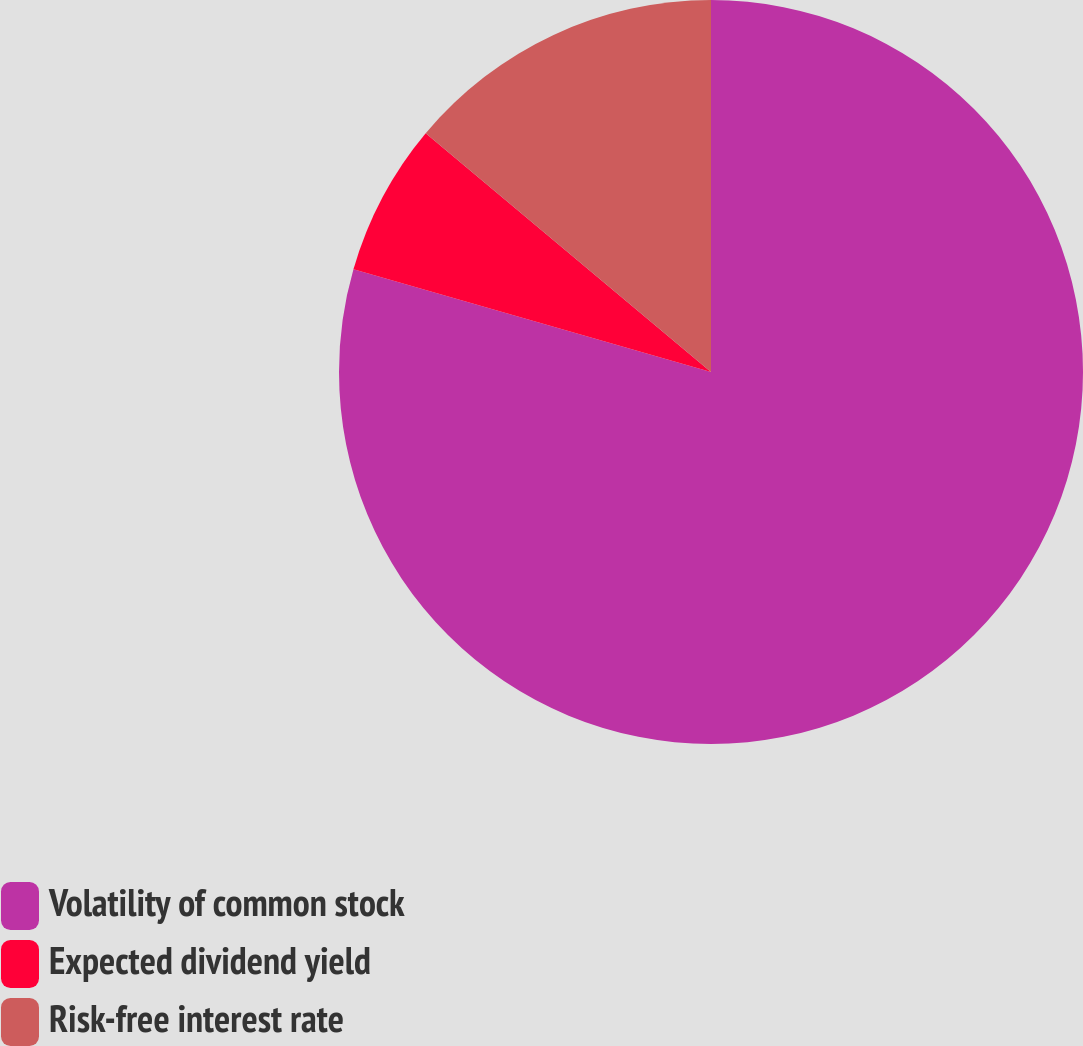Convert chart. <chart><loc_0><loc_0><loc_500><loc_500><pie_chart><fcel>Volatility of common stock<fcel>Expected dividend yield<fcel>Risk-free interest rate<nl><fcel>79.45%<fcel>6.64%<fcel>13.91%<nl></chart> 